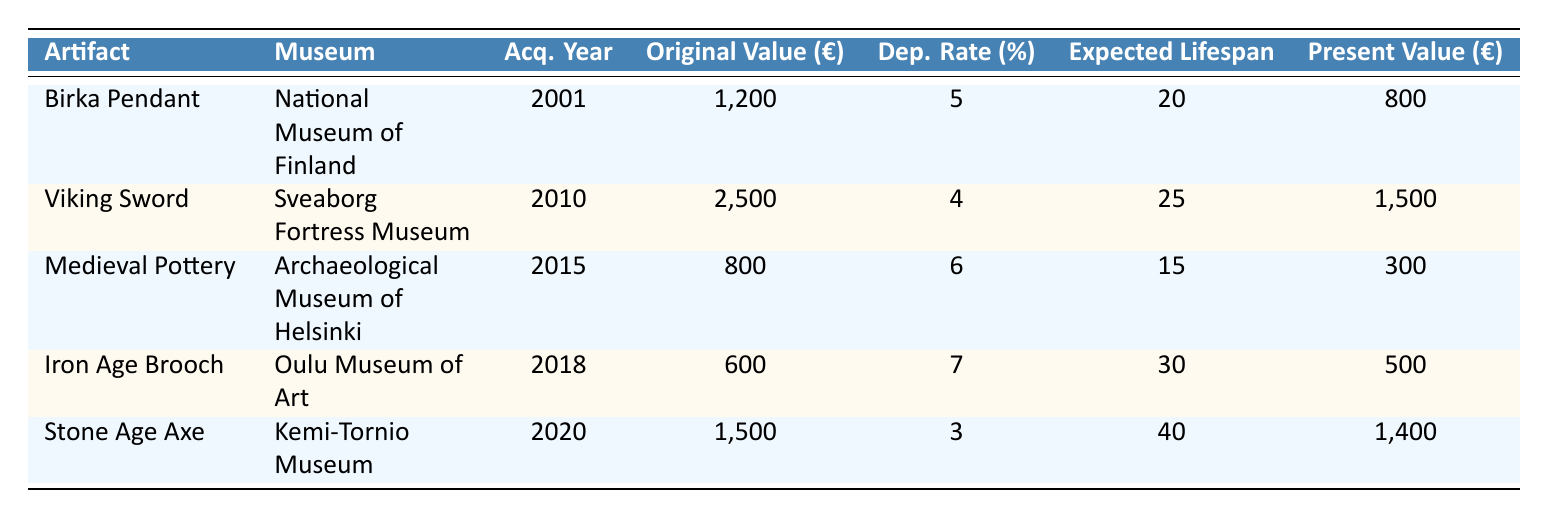What is the original value of the Viking Sword? The original value of the Viking Sword is specified directly in the table under the "Original Value (€)" column, which states it is 2500 euros.
Answer: 2500 Which artifact has the highest present value? To find the artifact with the highest present value, we should compare the values listed in the "Present Value (€)" column. The values are 800, 1500, 300, 500, and 1400 euros, and the highest among these is 1500 euros for the Viking Sword.
Answer: Viking Sword How many artifacts have a depreciation rate greater than 5%? We need to check the depreciation rates of each artifact listed in the table: 5%, 4%, 6%, 7%, and 3%. The rates greater than 5% are 6% (Medieval Pottery) and 7% (Iron Age Brooch). Thus, there are 2 artifacts with a depreciation rate greater than 5%.
Answer: 2 What is the average original value of the artifacts? We first sum the original values of all artifacts: 1200 + 2500 + 800 + 600 + 1500 = 5600 euros. There are 5 artifacts in total, so we divide the sum by the number of artifacts: 5600 / 5 = 1120 euros.
Answer: 1120 Is the expected lifespan of the Stone Age Axe longer than that of the Medieval Pottery? The expected lifespan of the Stone Age Axe is 40 years, and that of the Medieval Pottery is 15 years. Since 40 is greater than 15, the statement is true.
Answer: Yes What is the difference between the present values of the Birka Pendant and Iron Age Brooch? The present value of the Birka Pendant is 800 euros, while that of the Iron Age Brooch is 500 euros. To find the difference, we subtract these two values: 800 - 500 = 300 euros.
Answer: 300 Which museum houses the artifact with the lowest original value? We look for the lowest original value in the table, which is 600 euros for the Iron Age Brooch. The museum associated with it, as per the "Museum" column, is the Oulu Museum of Art.
Answer: Oulu Museum of Art Which artifacts have an expected lifespan of 30 years or more? We examine the "Expected Lifespan" column for values of 30 years or more. The Iron Age Brooch has 30 years, and the Stone Age Axe has 40 years, making them the only artifacts that meet this criterion.
Answer: Iron Age Brooch, Stone Age Axe 